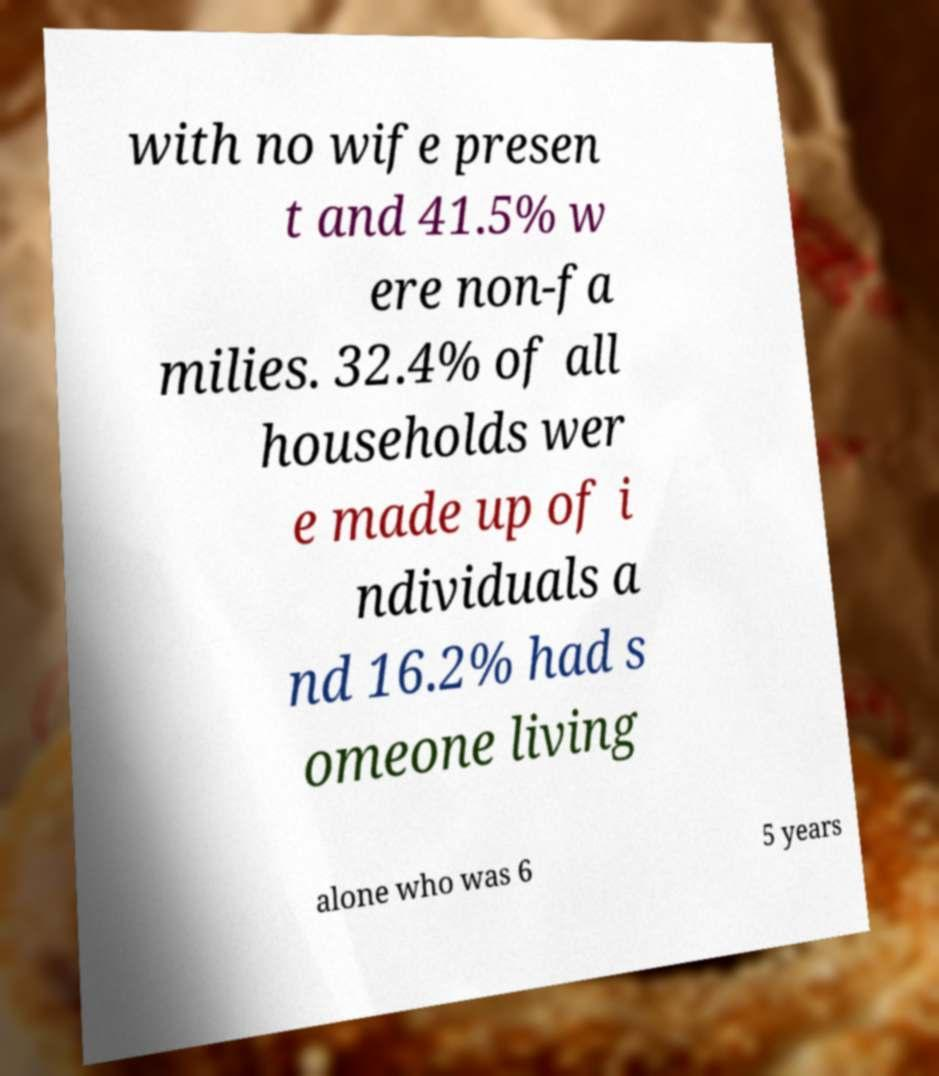There's text embedded in this image that I need extracted. Can you transcribe it verbatim? with no wife presen t and 41.5% w ere non-fa milies. 32.4% of all households wer e made up of i ndividuals a nd 16.2% had s omeone living alone who was 6 5 years 